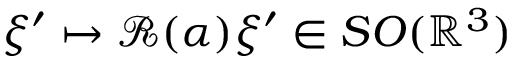<formula> <loc_0><loc_0><loc_500><loc_500>\xi ^ { \prime } \mapsto \mathcal { R } ( \alpha ) \xi ^ { \prime } \in S O ( \mathbb { R } ^ { 3 } )</formula> 